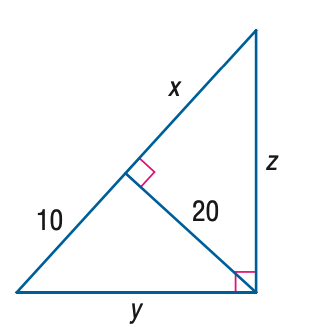Question: Find x.
Choices:
A. 10
B. 10 \sqrt { 2 }
C. 20
D. 40
Answer with the letter. Answer: D Question: Find y.
Choices:
A. 10
B. 10 \sqrt { 3 }
C. 20
D. 10 \sqrt { 5 }
Answer with the letter. Answer: D Question: Find z.
Choices:
A. 20
B. 20 \sqrt { 3 }
C. 40
D. 20 \sqrt { 5 }
Answer with the letter. Answer: D 